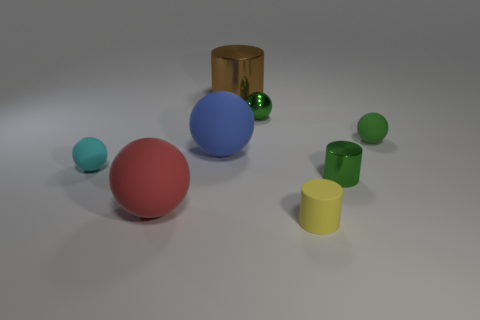There is a big red thing that is the same shape as the tiny green matte thing; what is its material?
Provide a short and direct response. Rubber. What number of objects are either green metal objects that are in front of the cyan thing or tiny green balls behind the green rubber ball?
Offer a terse response. 2. Do the small metallic cylinder and the tiny ball that is to the right of the tiny green metallic ball have the same color?
Ensure brevity in your answer.  Yes. The tiny green thing that is made of the same material as the tiny cyan thing is what shape?
Make the answer very short. Sphere. How many rubber blocks are there?
Offer a very short reply. 0. What number of objects are spheres that are to the left of the small green matte sphere or green cylinders?
Provide a succinct answer. 5. There is a small metallic thing in front of the large blue thing; does it have the same color as the shiny ball?
Your response must be concise. Yes. How many other things are the same color as the tiny metallic sphere?
Your answer should be compact. 2. How many large things are cyan rubber balls or yellow balls?
Your answer should be compact. 0. Is the number of brown cylinders greater than the number of small gray cylinders?
Give a very brief answer. Yes. 